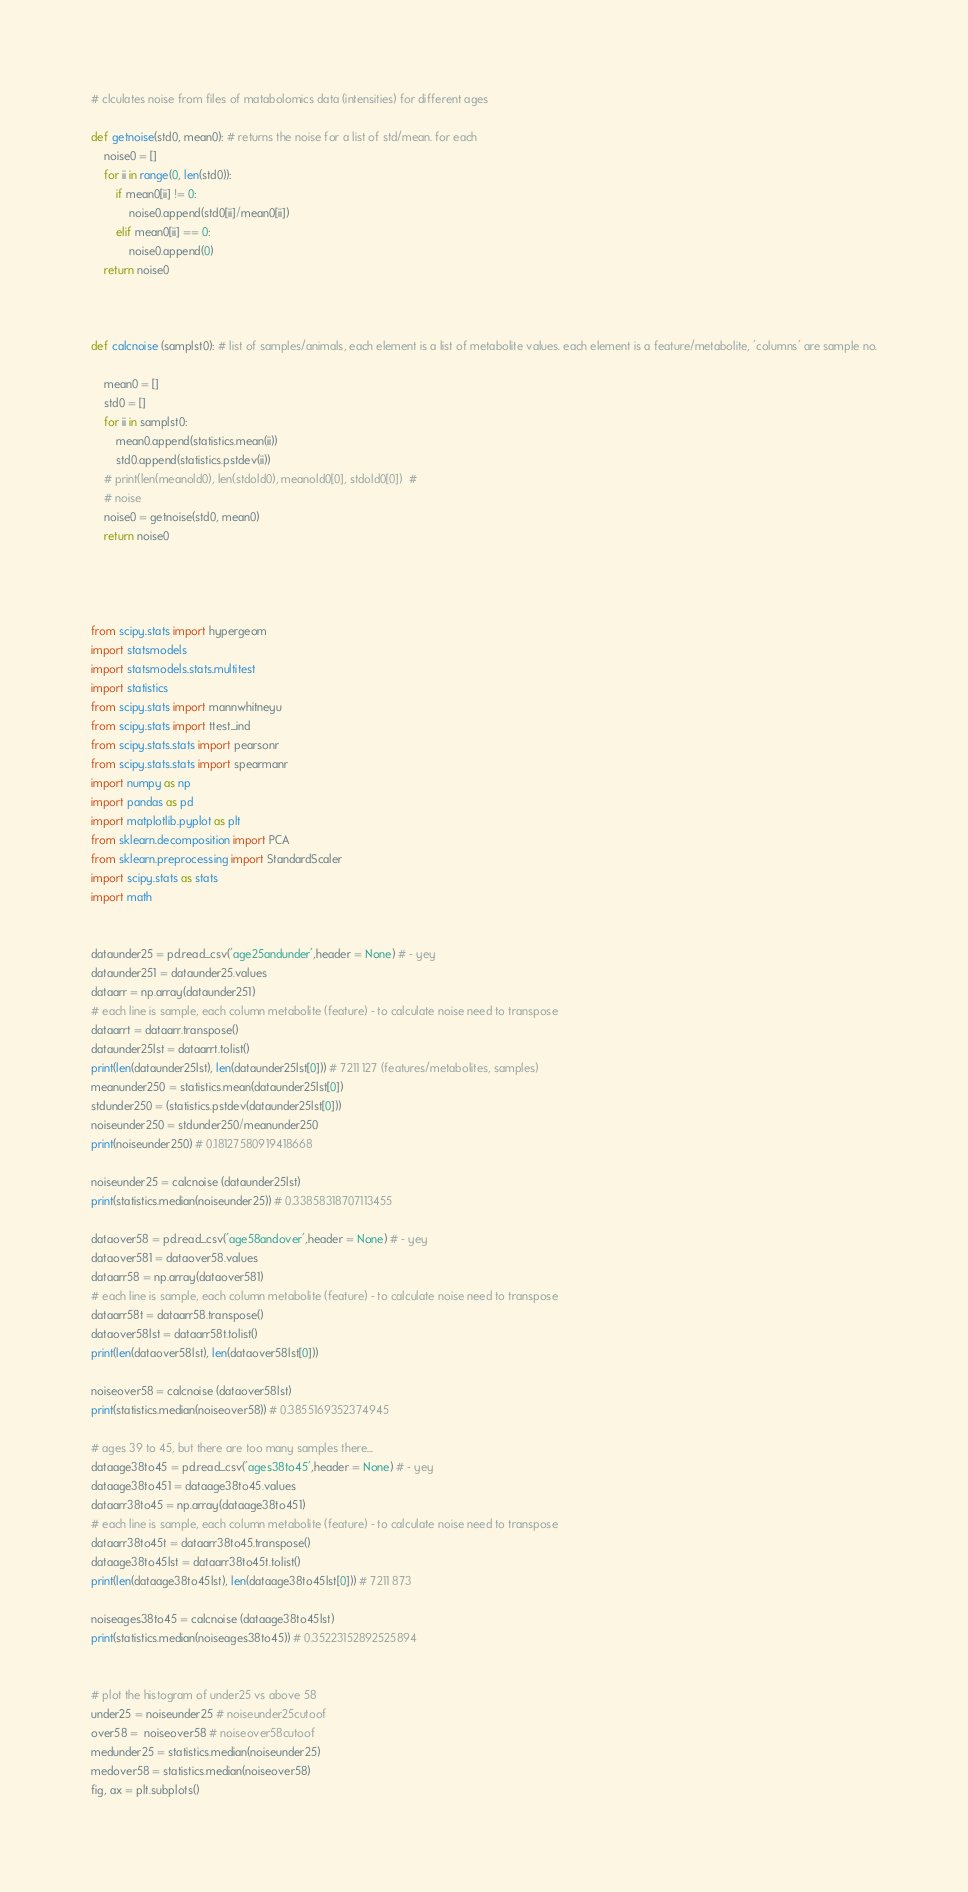<code> <loc_0><loc_0><loc_500><loc_500><_Python_>

# clculates noise from files of matabolomics data (intensities) for different ages

def getnoise(std0, mean0): # returns the noise for a list of std/mean. for each
    noise0 = []
    for ii in range(0, len(std0)):
        if mean0[ii] != 0:
            noise0.append(std0[ii]/mean0[ii])
        elif mean0[ii] == 0:
            noise0.append(0)
    return noise0



def calcnoise (samplst0): # list of samples/animals, each element is a list of metabolite values. each element is a feature/metabolite, 'columns' are sample no.

    mean0 = []
    std0 = []
    for ii in samplst0:
        mean0.append(statistics.mean(ii))
        std0.append(statistics.pstdev(ii))
    # print(len(meanold0), len(stdold0), meanold0[0], stdold0[0])  #
    # noise
    noise0 = getnoise(std0, mean0)
    return noise0




from scipy.stats import hypergeom
import statsmodels
import statsmodels.stats.multitest
import statistics
from scipy.stats import mannwhitneyu
from scipy.stats import ttest_ind
from scipy.stats.stats import pearsonr
from scipy.stats.stats import spearmanr
import numpy as np
import pandas as pd
import matplotlib.pyplot as plt
from sklearn.decomposition import PCA
from sklearn.preprocessing import StandardScaler
import scipy.stats as stats
import math


dataunder25 = pd.read_csv('age25andunder',header = None) # - yey
dataunder251 = dataunder25.values
dataarr = np.array(dataunder251)
# each line is sample, each column metabolite (feature) - to calculate noise need to transpose
dataarrt = dataarr.transpose()
dataunder25lst = dataarrt.tolist()
print(len(dataunder25lst), len(dataunder25lst[0])) # 7211 127 (features/metabolites, samples)
meanunder250 = statistics.mean(dataunder25lst[0])
stdunder250 = (statistics.pstdev(dataunder25lst[0]))
noiseunder250 = stdunder250/meanunder250
print(noiseunder250) # 0.18127580919418668

noiseunder25 = calcnoise (dataunder25lst)
print(statistics.median(noiseunder25)) # 0.33858318707113455

dataover58 = pd.read_csv('age58andover',header = None) # - yey
dataover581 = dataover58.values
dataarr58 = np.array(dataover581)
# each line is sample, each column metabolite (feature) - to calculate noise need to transpose
dataarr58t = dataarr58.transpose()
dataover58lst = dataarr58t.tolist()
print(len(dataover58lst), len(dataover58lst[0]))

noiseover58 = calcnoise (dataover58lst)
print(statistics.median(noiseover58)) # 0.3855169352374945

# ages 39 to 45, but there are too many samples there...
dataage38to45 = pd.read_csv('ages38to45',header = None) # - yey
dataage38to451 = dataage38to45.values
dataarr38to45 = np.array(dataage38to451)
# each line is sample, each column metabolite (feature) - to calculate noise need to transpose
dataarr38to45t = dataarr38to45.transpose()
dataage38to45lst = dataarr38to45t.tolist()
print(len(dataage38to45lst), len(dataage38to45lst[0])) # 7211 873

noiseages38to45 = calcnoise (dataage38to45lst)
print(statistics.median(noiseages38to45)) # 0.35223152892525894


# plot the histogram of under25 vs above 58
under25 = noiseunder25 # noiseunder25cutoof
over58 =  noiseover58 # noiseover58cutoof
medunder25 = statistics.median(noiseunder25)
medover58 = statistics.median(noiseover58)
fig, ax = plt.subplots()</code> 